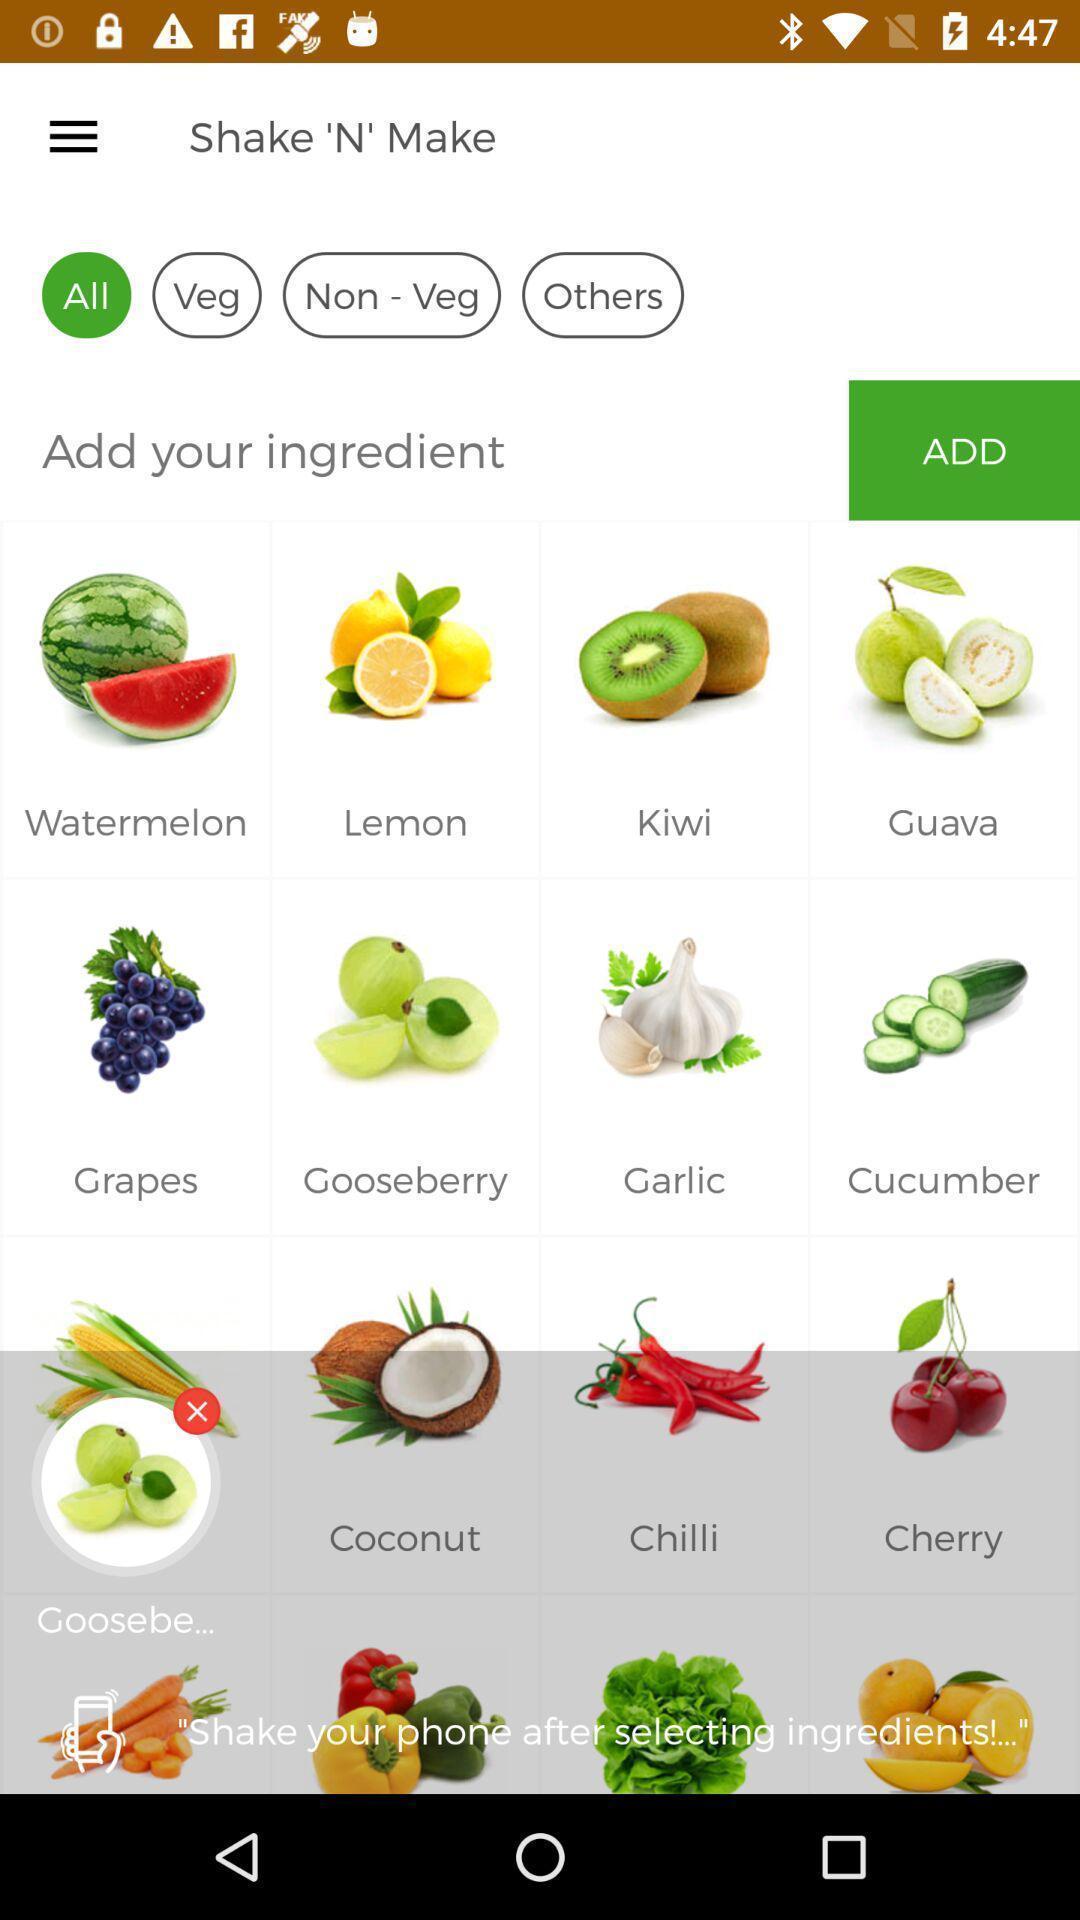Provide a detailed account of this screenshot. Screen displaying multiple food items with names. 